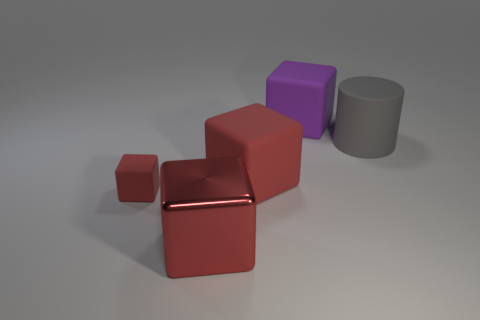Are there any metallic blocks behind the thing that is in front of the small rubber cube?
Provide a succinct answer. No. What number of other objects are there of the same shape as the tiny rubber thing?
Your answer should be compact. 3. There is a red matte thing that is behind the small red rubber cube; is it the same shape as the red object that is in front of the tiny red matte cube?
Your answer should be compact. Yes. How many blocks are behind the big object in front of the big matte cube that is in front of the gray rubber cylinder?
Ensure brevity in your answer.  3. What is the color of the shiny thing?
Your answer should be compact. Red. How many other things are there of the same size as the cylinder?
Your answer should be very brief. 3. There is a tiny red object that is the same shape as the purple rubber object; what is it made of?
Your answer should be compact. Rubber. There is a large red cube in front of the large red block that is behind the red matte block that is to the left of the big red metal cube; what is it made of?
Your answer should be compact. Metal. What size is the purple thing that is the same material as the large cylinder?
Provide a succinct answer. Large. Is there any other thing of the same color as the rubber cylinder?
Make the answer very short. No. 